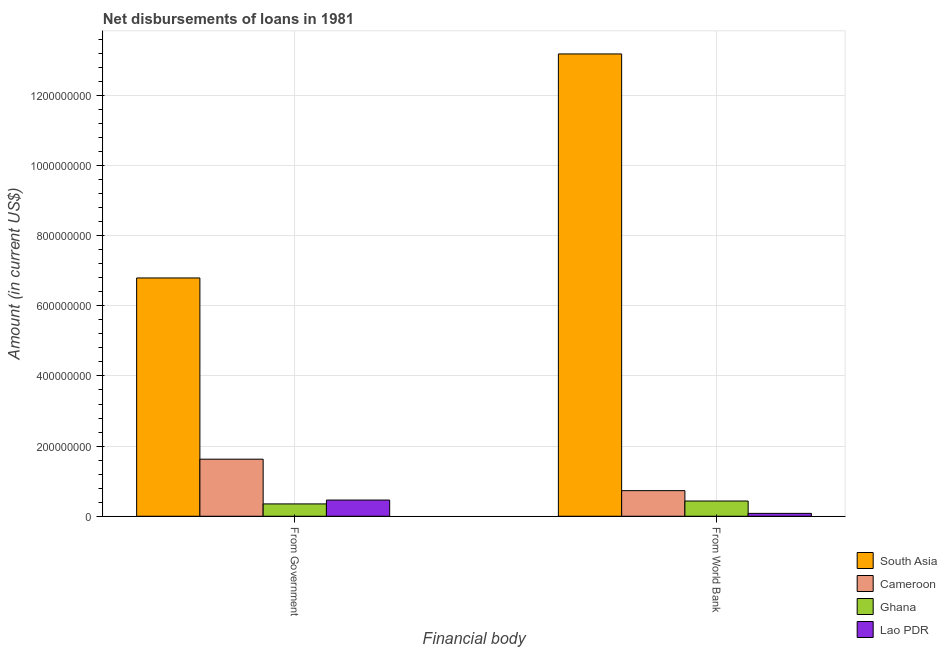How many different coloured bars are there?
Provide a short and direct response. 4. How many groups of bars are there?
Give a very brief answer. 2. Are the number of bars per tick equal to the number of legend labels?
Your answer should be very brief. Yes. How many bars are there on the 2nd tick from the left?
Offer a terse response. 4. What is the label of the 1st group of bars from the left?
Your answer should be compact. From Government. What is the net disbursements of loan from government in Cameroon?
Give a very brief answer. 1.63e+08. Across all countries, what is the maximum net disbursements of loan from world bank?
Offer a very short reply. 1.32e+09. Across all countries, what is the minimum net disbursements of loan from world bank?
Make the answer very short. 8.17e+06. In which country was the net disbursements of loan from government maximum?
Offer a very short reply. South Asia. In which country was the net disbursements of loan from world bank minimum?
Your answer should be compact. Lao PDR. What is the total net disbursements of loan from government in the graph?
Ensure brevity in your answer.  9.23e+08. What is the difference between the net disbursements of loan from world bank in Cameroon and that in Ghana?
Ensure brevity in your answer.  2.96e+07. What is the difference between the net disbursements of loan from government in Lao PDR and the net disbursements of loan from world bank in South Asia?
Your response must be concise. -1.27e+09. What is the average net disbursements of loan from world bank per country?
Your response must be concise. 3.61e+08. What is the difference between the net disbursements of loan from government and net disbursements of loan from world bank in Cameroon?
Your answer should be compact. 8.97e+07. In how many countries, is the net disbursements of loan from government greater than 480000000 US$?
Provide a short and direct response. 1. What is the ratio of the net disbursements of loan from world bank in Cameroon to that in South Asia?
Your response must be concise. 0.06. Is the net disbursements of loan from world bank in South Asia less than that in Cameroon?
Provide a short and direct response. No. What does the 2nd bar from the left in From World Bank represents?
Make the answer very short. Cameroon. What does the 3rd bar from the right in From Government represents?
Your answer should be very brief. Cameroon. How many bars are there?
Your answer should be compact. 8. How many countries are there in the graph?
Your response must be concise. 4. What is the difference between two consecutive major ticks on the Y-axis?
Offer a terse response. 2.00e+08. Does the graph contain any zero values?
Make the answer very short. No. Where does the legend appear in the graph?
Provide a short and direct response. Bottom right. How many legend labels are there?
Offer a very short reply. 4. What is the title of the graph?
Offer a terse response. Net disbursements of loans in 1981. Does "Cabo Verde" appear as one of the legend labels in the graph?
Keep it short and to the point. No. What is the label or title of the X-axis?
Keep it short and to the point. Financial body. What is the Amount (in current US$) of South Asia in From Government?
Your response must be concise. 6.79e+08. What is the Amount (in current US$) in Cameroon in From Government?
Your response must be concise. 1.63e+08. What is the Amount (in current US$) in Ghana in From Government?
Offer a terse response. 3.52e+07. What is the Amount (in current US$) of Lao PDR in From Government?
Offer a very short reply. 4.62e+07. What is the Amount (in current US$) of South Asia in From World Bank?
Provide a short and direct response. 1.32e+09. What is the Amount (in current US$) in Cameroon in From World Bank?
Your response must be concise. 7.30e+07. What is the Amount (in current US$) of Ghana in From World Bank?
Provide a short and direct response. 4.34e+07. What is the Amount (in current US$) in Lao PDR in From World Bank?
Your answer should be very brief. 8.17e+06. Across all Financial body, what is the maximum Amount (in current US$) in South Asia?
Offer a terse response. 1.32e+09. Across all Financial body, what is the maximum Amount (in current US$) of Cameroon?
Provide a short and direct response. 1.63e+08. Across all Financial body, what is the maximum Amount (in current US$) in Ghana?
Your response must be concise. 4.34e+07. Across all Financial body, what is the maximum Amount (in current US$) in Lao PDR?
Make the answer very short. 4.62e+07. Across all Financial body, what is the minimum Amount (in current US$) in South Asia?
Keep it short and to the point. 6.79e+08. Across all Financial body, what is the minimum Amount (in current US$) of Cameroon?
Ensure brevity in your answer.  7.30e+07. Across all Financial body, what is the minimum Amount (in current US$) of Ghana?
Offer a terse response. 3.52e+07. Across all Financial body, what is the minimum Amount (in current US$) of Lao PDR?
Make the answer very short. 8.17e+06. What is the total Amount (in current US$) in South Asia in the graph?
Provide a succinct answer. 2.00e+09. What is the total Amount (in current US$) in Cameroon in the graph?
Keep it short and to the point. 2.36e+08. What is the total Amount (in current US$) of Ghana in the graph?
Provide a short and direct response. 7.86e+07. What is the total Amount (in current US$) in Lao PDR in the graph?
Make the answer very short. 5.43e+07. What is the difference between the Amount (in current US$) in South Asia in From Government and that in From World Bank?
Your answer should be compact. -6.39e+08. What is the difference between the Amount (in current US$) in Cameroon in From Government and that in From World Bank?
Offer a terse response. 8.97e+07. What is the difference between the Amount (in current US$) of Ghana in From Government and that in From World Bank?
Offer a terse response. -8.25e+06. What is the difference between the Amount (in current US$) in Lao PDR in From Government and that in From World Bank?
Provide a short and direct response. 3.80e+07. What is the difference between the Amount (in current US$) of South Asia in From Government and the Amount (in current US$) of Cameroon in From World Bank?
Give a very brief answer. 6.06e+08. What is the difference between the Amount (in current US$) in South Asia in From Government and the Amount (in current US$) in Ghana in From World Bank?
Keep it short and to the point. 6.36e+08. What is the difference between the Amount (in current US$) of South Asia in From Government and the Amount (in current US$) of Lao PDR in From World Bank?
Offer a very short reply. 6.71e+08. What is the difference between the Amount (in current US$) in Cameroon in From Government and the Amount (in current US$) in Ghana in From World Bank?
Make the answer very short. 1.19e+08. What is the difference between the Amount (in current US$) in Cameroon in From Government and the Amount (in current US$) in Lao PDR in From World Bank?
Provide a succinct answer. 1.55e+08. What is the difference between the Amount (in current US$) in Ghana in From Government and the Amount (in current US$) in Lao PDR in From World Bank?
Your answer should be compact. 2.70e+07. What is the average Amount (in current US$) of South Asia per Financial body?
Keep it short and to the point. 9.99e+08. What is the average Amount (in current US$) of Cameroon per Financial body?
Your answer should be compact. 1.18e+08. What is the average Amount (in current US$) in Ghana per Financial body?
Provide a short and direct response. 3.93e+07. What is the average Amount (in current US$) of Lao PDR per Financial body?
Your answer should be very brief. 2.72e+07. What is the difference between the Amount (in current US$) in South Asia and Amount (in current US$) in Cameroon in From Government?
Provide a short and direct response. 5.17e+08. What is the difference between the Amount (in current US$) in South Asia and Amount (in current US$) in Ghana in From Government?
Provide a succinct answer. 6.44e+08. What is the difference between the Amount (in current US$) of South Asia and Amount (in current US$) of Lao PDR in From Government?
Offer a very short reply. 6.33e+08. What is the difference between the Amount (in current US$) of Cameroon and Amount (in current US$) of Ghana in From Government?
Keep it short and to the point. 1.28e+08. What is the difference between the Amount (in current US$) of Cameroon and Amount (in current US$) of Lao PDR in From Government?
Give a very brief answer. 1.17e+08. What is the difference between the Amount (in current US$) of Ghana and Amount (in current US$) of Lao PDR in From Government?
Your answer should be very brief. -1.10e+07. What is the difference between the Amount (in current US$) in South Asia and Amount (in current US$) in Cameroon in From World Bank?
Keep it short and to the point. 1.25e+09. What is the difference between the Amount (in current US$) of South Asia and Amount (in current US$) of Ghana in From World Bank?
Provide a short and direct response. 1.27e+09. What is the difference between the Amount (in current US$) of South Asia and Amount (in current US$) of Lao PDR in From World Bank?
Give a very brief answer. 1.31e+09. What is the difference between the Amount (in current US$) of Cameroon and Amount (in current US$) of Ghana in From World Bank?
Your response must be concise. 2.96e+07. What is the difference between the Amount (in current US$) in Cameroon and Amount (in current US$) in Lao PDR in From World Bank?
Your answer should be very brief. 6.48e+07. What is the difference between the Amount (in current US$) of Ghana and Amount (in current US$) of Lao PDR in From World Bank?
Ensure brevity in your answer.  3.53e+07. What is the ratio of the Amount (in current US$) in South Asia in From Government to that in From World Bank?
Give a very brief answer. 0.52. What is the ratio of the Amount (in current US$) in Cameroon in From Government to that in From World Bank?
Your answer should be very brief. 2.23. What is the ratio of the Amount (in current US$) in Ghana in From Government to that in From World Bank?
Offer a very short reply. 0.81. What is the ratio of the Amount (in current US$) in Lao PDR in From Government to that in From World Bank?
Your answer should be compact. 5.65. What is the difference between the highest and the second highest Amount (in current US$) of South Asia?
Give a very brief answer. 6.39e+08. What is the difference between the highest and the second highest Amount (in current US$) of Cameroon?
Provide a short and direct response. 8.97e+07. What is the difference between the highest and the second highest Amount (in current US$) in Ghana?
Your response must be concise. 8.25e+06. What is the difference between the highest and the second highest Amount (in current US$) of Lao PDR?
Ensure brevity in your answer.  3.80e+07. What is the difference between the highest and the lowest Amount (in current US$) in South Asia?
Your response must be concise. 6.39e+08. What is the difference between the highest and the lowest Amount (in current US$) in Cameroon?
Your response must be concise. 8.97e+07. What is the difference between the highest and the lowest Amount (in current US$) in Ghana?
Give a very brief answer. 8.25e+06. What is the difference between the highest and the lowest Amount (in current US$) of Lao PDR?
Provide a succinct answer. 3.80e+07. 